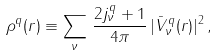<formula> <loc_0><loc_0><loc_500><loc_500>\rho ^ { q } ( r ) \equiv \sum _ { \nu } \, \frac { 2 j ^ { q } _ { \nu } + 1 } { 4 \pi } \, | \bar { V } ^ { q } _ { \nu } ( r ) | ^ { 2 } \, ,</formula> 